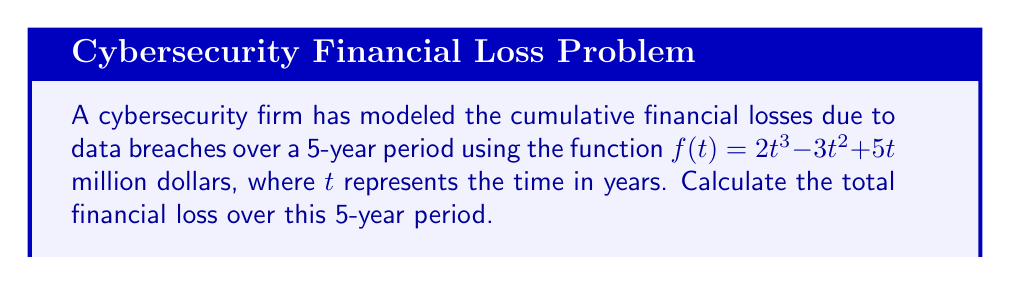What is the answer to this math problem? To calculate the total financial loss over the 5-year period, we need to find the area under the curve represented by $f(t)$ from $t=0$ to $t=5$. This can be done using a definite integral.

Step 1: Set up the definite integral
$$\int_0^5 (2t^3 - 3t^2 + 5t) dt$$

Step 2: Integrate the function
$\int (2t^3 - 3t^2 + 5t) dt = \frac{1}{2}t^4 - t^3 + \frac{5}{2}t^2 + C$

Step 3: Apply the limits of integration
$$[\frac{1}{2}t^4 - t^3 + \frac{5}{2}t^2]_0^5$$

Step 4: Evaluate the function at the upper limit (t=5)
$\frac{1}{2}(5^4) - (5^3) + \frac{5}{2}(5^2) = 312.5 - 125 + 62.5 = 250$

Step 5: Evaluate the function at the lower limit (t=0)
$\frac{1}{2}(0^4) - (0^3) + \frac{5}{2}(0^2) = 0$

Step 6: Subtract the lower limit result from the upper limit result
$250 - 0 = 250$

Therefore, the total financial loss over the 5-year period is 250 million dollars.
Answer: $250$ million dollars 